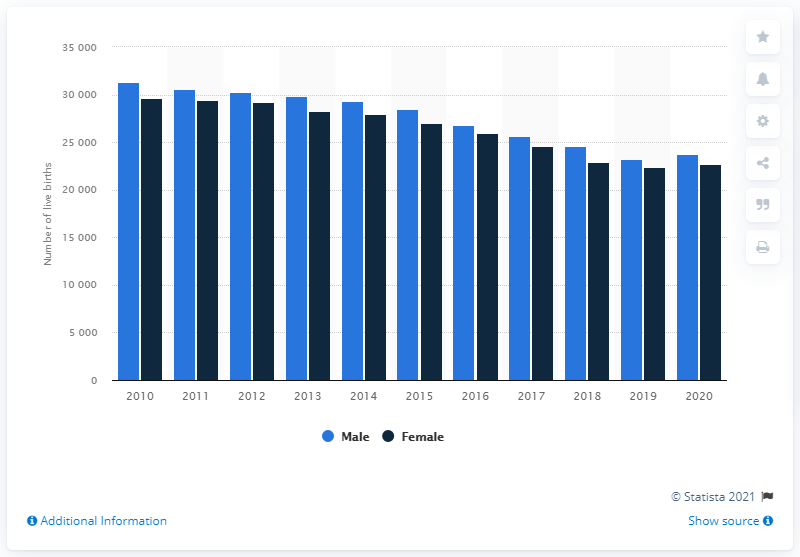List a handful of essential elements in this visual. It is predicted that the number of live births in Finland will increase again in 2020. 